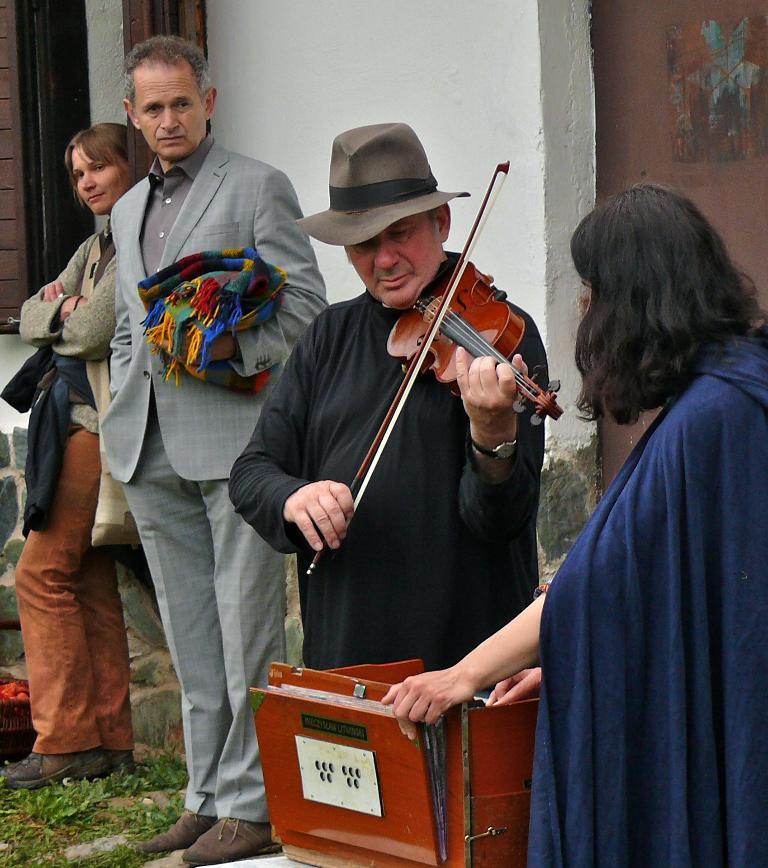Can you describe this image briefly? In this picture we can see two men and two woman where here man holding violin and playing it where this woman is playing accordion and in background we can see wall. 